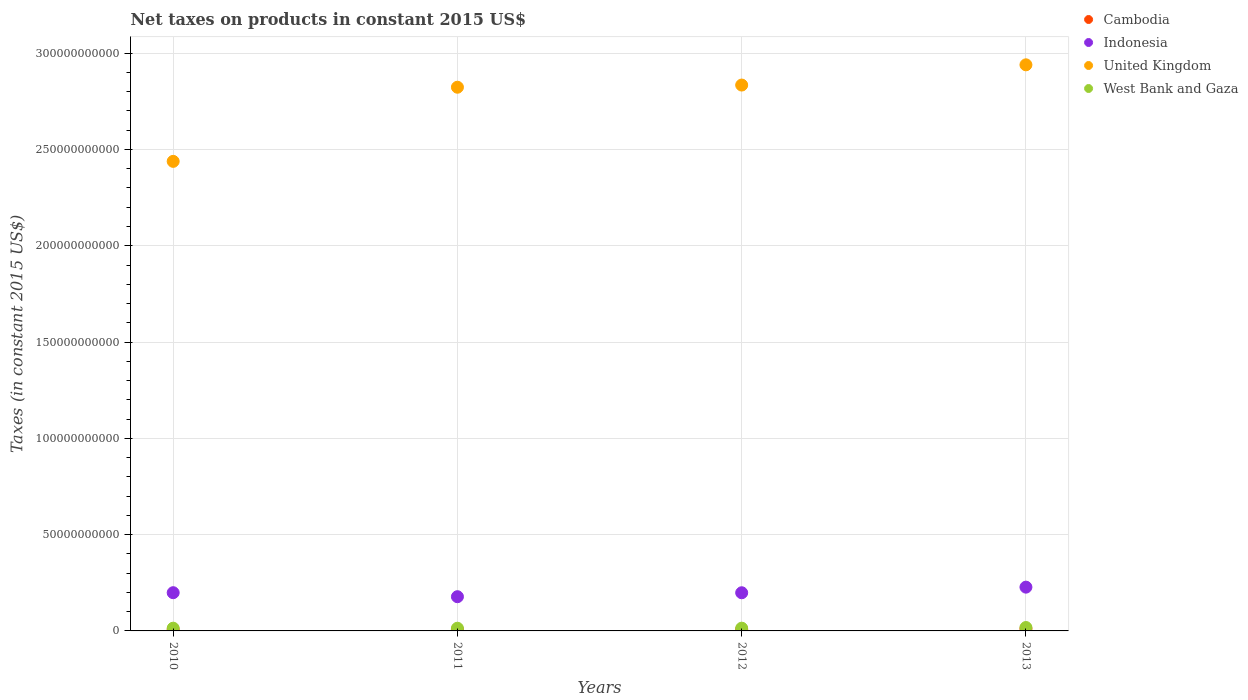Is the number of dotlines equal to the number of legend labels?
Your answer should be very brief. Yes. What is the net taxes on products in United Kingdom in 2010?
Ensure brevity in your answer.  2.44e+11. Across all years, what is the maximum net taxes on products in United Kingdom?
Keep it short and to the point. 2.94e+11. Across all years, what is the minimum net taxes on products in Cambodia?
Your answer should be compact. 6.69e+08. In which year was the net taxes on products in West Bank and Gaza minimum?
Provide a short and direct response. 2011. What is the total net taxes on products in United Kingdom in the graph?
Provide a succinct answer. 1.10e+12. What is the difference between the net taxes on products in West Bank and Gaza in 2011 and that in 2012?
Offer a terse response. -2.49e+07. What is the difference between the net taxes on products in Cambodia in 2011 and the net taxes on products in West Bank and Gaza in 2010?
Keep it short and to the point. -6.77e+08. What is the average net taxes on products in United Kingdom per year?
Provide a short and direct response. 2.76e+11. In the year 2010, what is the difference between the net taxes on products in Cambodia and net taxes on products in West Bank and Gaza?
Offer a terse response. -7.52e+08. In how many years, is the net taxes on products in Cambodia greater than 270000000000 US$?
Give a very brief answer. 0. What is the ratio of the net taxes on products in West Bank and Gaza in 2011 to that in 2013?
Ensure brevity in your answer.  0.79. What is the difference between the highest and the second highest net taxes on products in West Bank and Gaza?
Your answer should be compact. 3.43e+08. What is the difference between the highest and the lowest net taxes on products in United Kingdom?
Your response must be concise. 5.01e+1. Is it the case that in every year, the sum of the net taxes on products in United Kingdom and net taxes on products in Cambodia  is greater than the sum of net taxes on products in West Bank and Gaza and net taxes on products in Indonesia?
Make the answer very short. Yes. Is the net taxes on products in West Bank and Gaza strictly greater than the net taxes on products in United Kingdom over the years?
Offer a very short reply. No. What is the difference between two consecutive major ticks on the Y-axis?
Your answer should be very brief. 5.00e+1. Are the values on the major ticks of Y-axis written in scientific E-notation?
Offer a very short reply. No. Does the graph contain grids?
Your answer should be compact. Yes. Where does the legend appear in the graph?
Offer a terse response. Top right. How many legend labels are there?
Offer a terse response. 4. What is the title of the graph?
Ensure brevity in your answer.  Net taxes on products in constant 2015 US$. What is the label or title of the Y-axis?
Offer a terse response. Taxes (in constant 2015 US$). What is the Taxes (in constant 2015 US$) of Cambodia in 2010?
Provide a succinct answer. 6.69e+08. What is the Taxes (in constant 2015 US$) in Indonesia in 2010?
Your answer should be very brief. 1.99e+1. What is the Taxes (in constant 2015 US$) of United Kingdom in 2010?
Your answer should be very brief. 2.44e+11. What is the Taxes (in constant 2015 US$) of West Bank and Gaza in 2010?
Your answer should be very brief. 1.42e+09. What is the Taxes (in constant 2015 US$) of Cambodia in 2011?
Your answer should be compact. 7.44e+08. What is the Taxes (in constant 2015 US$) in Indonesia in 2011?
Ensure brevity in your answer.  1.78e+1. What is the Taxes (in constant 2015 US$) of United Kingdom in 2011?
Your response must be concise. 2.82e+11. What is the Taxes (in constant 2015 US$) in West Bank and Gaza in 2011?
Provide a short and direct response. 1.40e+09. What is the Taxes (in constant 2015 US$) of Cambodia in 2012?
Keep it short and to the point. 8.06e+08. What is the Taxes (in constant 2015 US$) of Indonesia in 2012?
Offer a very short reply. 1.98e+1. What is the Taxes (in constant 2015 US$) of United Kingdom in 2012?
Your response must be concise. 2.83e+11. What is the Taxes (in constant 2015 US$) in West Bank and Gaza in 2012?
Provide a short and direct response. 1.42e+09. What is the Taxes (in constant 2015 US$) in Cambodia in 2013?
Offer a terse response. 1.09e+09. What is the Taxes (in constant 2015 US$) in Indonesia in 2013?
Your answer should be compact. 2.27e+1. What is the Taxes (in constant 2015 US$) of United Kingdom in 2013?
Offer a terse response. 2.94e+11. What is the Taxes (in constant 2015 US$) of West Bank and Gaza in 2013?
Give a very brief answer. 1.77e+09. Across all years, what is the maximum Taxes (in constant 2015 US$) in Cambodia?
Offer a terse response. 1.09e+09. Across all years, what is the maximum Taxes (in constant 2015 US$) of Indonesia?
Offer a very short reply. 2.27e+1. Across all years, what is the maximum Taxes (in constant 2015 US$) of United Kingdom?
Provide a short and direct response. 2.94e+11. Across all years, what is the maximum Taxes (in constant 2015 US$) of West Bank and Gaza?
Your answer should be very brief. 1.77e+09. Across all years, what is the minimum Taxes (in constant 2015 US$) of Cambodia?
Provide a short and direct response. 6.69e+08. Across all years, what is the minimum Taxes (in constant 2015 US$) of Indonesia?
Make the answer very short. 1.78e+1. Across all years, what is the minimum Taxes (in constant 2015 US$) of United Kingdom?
Ensure brevity in your answer.  2.44e+11. Across all years, what is the minimum Taxes (in constant 2015 US$) in West Bank and Gaza?
Give a very brief answer. 1.40e+09. What is the total Taxes (in constant 2015 US$) in Cambodia in the graph?
Offer a very short reply. 3.31e+09. What is the total Taxes (in constant 2015 US$) of Indonesia in the graph?
Ensure brevity in your answer.  8.02e+1. What is the total Taxes (in constant 2015 US$) of United Kingdom in the graph?
Your answer should be compact. 1.10e+12. What is the total Taxes (in constant 2015 US$) of West Bank and Gaza in the graph?
Offer a very short reply. 6.01e+09. What is the difference between the Taxes (in constant 2015 US$) in Cambodia in 2010 and that in 2011?
Provide a succinct answer. -7.49e+07. What is the difference between the Taxes (in constant 2015 US$) in Indonesia in 2010 and that in 2011?
Your answer should be very brief. 2.08e+09. What is the difference between the Taxes (in constant 2015 US$) in United Kingdom in 2010 and that in 2011?
Ensure brevity in your answer.  -3.85e+1. What is the difference between the Taxes (in constant 2015 US$) in West Bank and Gaza in 2010 and that in 2011?
Your answer should be compact. 2.16e+07. What is the difference between the Taxes (in constant 2015 US$) of Cambodia in 2010 and that in 2012?
Provide a short and direct response. -1.37e+08. What is the difference between the Taxes (in constant 2015 US$) in Indonesia in 2010 and that in 2012?
Your response must be concise. 3.49e+07. What is the difference between the Taxes (in constant 2015 US$) in United Kingdom in 2010 and that in 2012?
Provide a succinct answer. -3.96e+1. What is the difference between the Taxes (in constant 2015 US$) of West Bank and Gaza in 2010 and that in 2012?
Keep it short and to the point. -3.32e+06. What is the difference between the Taxes (in constant 2015 US$) of Cambodia in 2010 and that in 2013?
Your answer should be compact. -4.25e+08. What is the difference between the Taxes (in constant 2015 US$) in Indonesia in 2010 and that in 2013?
Your answer should be compact. -2.88e+09. What is the difference between the Taxes (in constant 2015 US$) in United Kingdom in 2010 and that in 2013?
Ensure brevity in your answer.  -5.01e+1. What is the difference between the Taxes (in constant 2015 US$) in West Bank and Gaza in 2010 and that in 2013?
Your response must be concise. -3.46e+08. What is the difference between the Taxes (in constant 2015 US$) in Cambodia in 2011 and that in 2012?
Provide a succinct answer. -6.22e+07. What is the difference between the Taxes (in constant 2015 US$) of Indonesia in 2011 and that in 2012?
Your answer should be very brief. -2.05e+09. What is the difference between the Taxes (in constant 2015 US$) of United Kingdom in 2011 and that in 2012?
Give a very brief answer. -1.12e+09. What is the difference between the Taxes (in constant 2015 US$) of West Bank and Gaza in 2011 and that in 2012?
Keep it short and to the point. -2.49e+07. What is the difference between the Taxes (in constant 2015 US$) of Cambodia in 2011 and that in 2013?
Offer a terse response. -3.50e+08. What is the difference between the Taxes (in constant 2015 US$) in Indonesia in 2011 and that in 2013?
Keep it short and to the point. -4.96e+09. What is the difference between the Taxes (in constant 2015 US$) in United Kingdom in 2011 and that in 2013?
Offer a terse response. -1.16e+1. What is the difference between the Taxes (in constant 2015 US$) in West Bank and Gaza in 2011 and that in 2013?
Offer a very short reply. -3.68e+08. What is the difference between the Taxes (in constant 2015 US$) of Cambodia in 2012 and that in 2013?
Provide a succinct answer. -2.88e+08. What is the difference between the Taxes (in constant 2015 US$) of Indonesia in 2012 and that in 2013?
Provide a short and direct response. -2.92e+09. What is the difference between the Taxes (in constant 2015 US$) in United Kingdom in 2012 and that in 2013?
Offer a very short reply. -1.05e+1. What is the difference between the Taxes (in constant 2015 US$) of West Bank and Gaza in 2012 and that in 2013?
Make the answer very short. -3.43e+08. What is the difference between the Taxes (in constant 2015 US$) of Cambodia in 2010 and the Taxes (in constant 2015 US$) of Indonesia in 2011?
Offer a terse response. -1.71e+1. What is the difference between the Taxes (in constant 2015 US$) of Cambodia in 2010 and the Taxes (in constant 2015 US$) of United Kingdom in 2011?
Provide a succinct answer. -2.82e+11. What is the difference between the Taxes (in constant 2015 US$) of Cambodia in 2010 and the Taxes (in constant 2015 US$) of West Bank and Gaza in 2011?
Your answer should be compact. -7.30e+08. What is the difference between the Taxes (in constant 2015 US$) in Indonesia in 2010 and the Taxes (in constant 2015 US$) in United Kingdom in 2011?
Provide a short and direct response. -2.62e+11. What is the difference between the Taxes (in constant 2015 US$) of Indonesia in 2010 and the Taxes (in constant 2015 US$) of West Bank and Gaza in 2011?
Ensure brevity in your answer.  1.85e+1. What is the difference between the Taxes (in constant 2015 US$) of United Kingdom in 2010 and the Taxes (in constant 2015 US$) of West Bank and Gaza in 2011?
Ensure brevity in your answer.  2.42e+11. What is the difference between the Taxes (in constant 2015 US$) in Cambodia in 2010 and the Taxes (in constant 2015 US$) in Indonesia in 2012?
Offer a terse response. -1.91e+1. What is the difference between the Taxes (in constant 2015 US$) of Cambodia in 2010 and the Taxes (in constant 2015 US$) of United Kingdom in 2012?
Provide a short and direct response. -2.83e+11. What is the difference between the Taxes (in constant 2015 US$) in Cambodia in 2010 and the Taxes (in constant 2015 US$) in West Bank and Gaza in 2012?
Offer a terse response. -7.55e+08. What is the difference between the Taxes (in constant 2015 US$) in Indonesia in 2010 and the Taxes (in constant 2015 US$) in United Kingdom in 2012?
Provide a succinct answer. -2.64e+11. What is the difference between the Taxes (in constant 2015 US$) of Indonesia in 2010 and the Taxes (in constant 2015 US$) of West Bank and Gaza in 2012?
Keep it short and to the point. 1.84e+1. What is the difference between the Taxes (in constant 2015 US$) in United Kingdom in 2010 and the Taxes (in constant 2015 US$) in West Bank and Gaza in 2012?
Give a very brief answer. 2.42e+11. What is the difference between the Taxes (in constant 2015 US$) in Cambodia in 2010 and the Taxes (in constant 2015 US$) in Indonesia in 2013?
Your answer should be compact. -2.21e+1. What is the difference between the Taxes (in constant 2015 US$) in Cambodia in 2010 and the Taxes (in constant 2015 US$) in United Kingdom in 2013?
Provide a short and direct response. -2.93e+11. What is the difference between the Taxes (in constant 2015 US$) of Cambodia in 2010 and the Taxes (in constant 2015 US$) of West Bank and Gaza in 2013?
Offer a terse response. -1.10e+09. What is the difference between the Taxes (in constant 2015 US$) in Indonesia in 2010 and the Taxes (in constant 2015 US$) in United Kingdom in 2013?
Your response must be concise. -2.74e+11. What is the difference between the Taxes (in constant 2015 US$) in Indonesia in 2010 and the Taxes (in constant 2015 US$) in West Bank and Gaza in 2013?
Provide a succinct answer. 1.81e+1. What is the difference between the Taxes (in constant 2015 US$) in United Kingdom in 2010 and the Taxes (in constant 2015 US$) in West Bank and Gaza in 2013?
Ensure brevity in your answer.  2.42e+11. What is the difference between the Taxes (in constant 2015 US$) in Cambodia in 2011 and the Taxes (in constant 2015 US$) in Indonesia in 2012?
Provide a short and direct response. -1.91e+1. What is the difference between the Taxes (in constant 2015 US$) of Cambodia in 2011 and the Taxes (in constant 2015 US$) of United Kingdom in 2012?
Your answer should be compact. -2.83e+11. What is the difference between the Taxes (in constant 2015 US$) of Cambodia in 2011 and the Taxes (in constant 2015 US$) of West Bank and Gaza in 2012?
Provide a succinct answer. -6.80e+08. What is the difference between the Taxes (in constant 2015 US$) in Indonesia in 2011 and the Taxes (in constant 2015 US$) in United Kingdom in 2012?
Keep it short and to the point. -2.66e+11. What is the difference between the Taxes (in constant 2015 US$) in Indonesia in 2011 and the Taxes (in constant 2015 US$) in West Bank and Gaza in 2012?
Provide a short and direct response. 1.63e+1. What is the difference between the Taxes (in constant 2015 US$) of United Kingdom in 2011 and the Taxes (in constant 2015 US$) of West Bank and Gaza in 2012?
Keep it short and to the point. 2.81e+11. What is the difference between the Taxes (in constant 2015 US$) of Cambodia in 2011 and the Taxes (in constant 2015 US$) of Indonesia in 2013?
Your answer should be compact. -2.20e+1. What is the difference between the Taxes (in constant 2015 US$) in Cambodia in 2011 and the Taxes (in constant 2015 US$) in United Kingdom in 2013?
Keep it short and to the point. -2.93e+11. What is the difference between the Taxes (in constant 2015 US$) in Cambodia in 2011 and the Taxes (in constant 2015 US$) in West Bank and Gaza in 2013?
Give a very brief answer. -1.02e+09. What is the difference between the Taxes (in constant 2015 US$) in Indonesia in 2011 and the Taxes (in constant 2015 US$) in United Kingdom in 2013?
Make the answer very short. -2.76e+11. What is the difference between the Taxes (in constant 2015 US$) in Indonesia in 2011 and the Taxes (in constant 2015 US$) in West Bank and Gaza in 2013?
Your answer should be compact. 1.60e+1. What is the difference between the Taxes (in constant 2015 US$) of United Kingdom in 2011 and the Taxes (in constant 2015 US$) of West Bank and Gaza in 2013?
Make the answer very short. 2.81e+11. What is the difference between the Taxes (in constant 2015 US$) of Cambodia in 2012 and the Taxes (in constant 2015 US$) of Indonesia in 2013?
Your response must be concise. -2.19e+1. What is the difference between the Taxes (in constant 2015 US$) in Cambodia in 2012 and the Taxes (in constant 2015 US$) in United Kingdom in 2013?
Give a very brief answer. -2.93e+11. What is the difference between the Taxes (in constant 2015 US$) in Cambodia in 2012 and the Taxes (in constant 2015 US$) in West Bank and Gaza in 2013?
Ensure brevity in your answer.  -9.61e+08. What is the difference between the Taxes (in constant 2015 US$) of Indonesia in 2012 and the Taxes (in constant 2015 US$) of United Kingdom in 2013?
Offer a terse response. -2.74e+11. What is the difference between the Taxes (in constant 2015 US$) of Indonesia in 2012 and the Taxes (in constant 2015 US$) of West Bank and Gaza in 2013?
Provide a short and direct response. 1.80e+1. What is the difference between the Taxes (in constant 2015 US$) in United Kingdom in 2012 and the Taxes (in constant 2015 US$) in West Bank and Gaza in 2013?
Keep it short and to the point. 2.82e+11. What is the average Taxes (in constant 2015 US$) in Cambodia per year?
Ensure brevity in your answer.  8.28e+08. What is the average Taxes (in constant 2015 US$) in Indonesia per year?
Give a very brief answer. 2.00e+1. What is the average Taxes (in constant 2015 US$) in United Kingdom per year?
Offer a very short reply. 2.76e+11. What is the average Taxes (in constant 2015 US$) in West Bank and Gaza per year?
Provide a succinct answer. 1.50e+09. In the year 2010, what is the difference between the Taxes (in constant 2015 US$) of Cambodia and Taxes (in constant 2015 US$) of Indonesia?
Ensure brevity in your answer.  -1.92e+1. In the year 2010, what is the difference between the Taxes (in constant 2015 US$) of Cambodia and Taxes (in constant 2015 US$) of United Kingdom?
Provide a short and direct response. -2.43e+11. In the year 2010, what is the difference between the Taxes (in constant 2015 US$) in Cambodia and Taxes (in constant 2015 US$) in West Bank and Gaza?
Give a very brief answer. -7.52e+08. In the year 2010, what is the difference between the Taxes (in constant 2015 US$) in Indonesia and Taxes (in constant 2015 US$) in United Kingdom?
Offer a very short reply. -2.24e+11. In the year 2010, what is the difference between the Taxes (in constant 2015 US$) of Indonesia and Taxes (in constant 2015 US$) of West Bank and Gaza?
Your answer should be compact. 1.84e+1. In the year 2010, what is the difference between the Taxes (in constant 2015 US$) of United Kingdom and Taxes (in constant 2015 US$) of West Bank and Gaza?
Ensure brevity in your answer.  2.42e+11. In the year 2011, what is the difference between the Taxes (in constant 2015 US$) of Cambodia and Taxes (in constant 2015 US$) of Indonesia?
Keep it short and to the point. -1.70e+1. In the year 2011, what is the difference between the Taxes (in constant 2015 US$) of Cambodia and Taxes (in constant 2015 US$) of United Kingdom?
Ensure brevity in your answer.  -2.82e+11. In the year 2011, what is the difference between the Taxes (in constant 2015 US$) of Cambodia and Taxes (in constant 2015 US$) of West Bank and Gaza?
Your answer should be compact. -6.55e+08. In the year 2011, what is the difference between the Taxes (in constant 2015 US$) in Indonesia and Taxes (in constant 2015 US$) in United Kingdom?
Offer a terse response. -2.65e+11. In the year 2011, what is the difference between the Taxes (in constant 2015 US$) in Indonesia and Taxes (in constant 2015 US$) in West Bank and Gaza?
Offer a terse response. 1.64e+1. In the year 2011, what is the difference between the Taxes (in constant 2015 US$) of United Kingdom and Taxes (in constant 2015 US$) of West Bank and Gaza?
Make the answer very short. 2.81e+11. In the year 2012, what is the difference between the Taxes (in constant 2015 US$) of Cambodia and Taxes (in constant 2015 US$) of Indonesia?
Keep it short and to the point. -1.90e+1. In the year 2012, what is the difference between the Taxes (in constant 2015 US$) of Cambodia and Taxes (in constant 2015 US$) of United Kingdom?
Make the answer very short. -2.83e+11. In the year 2012, what is the difference between the Taxes (in constant 2015 US$) of Cambodia and Taxes (in constant 2015 US$) of West Bank and Gaza?
Offer a very short reply. -6.18e+08. In the year 2012, what is the difference between the Taxes (in constant 2015 US$) in Indonesia and Taxes (in constant 2015 US$) in United Kingdom?
Ensure brevity in your answer.  -2.64e+11. In the year 2012, what is the difference between the Taxes (in constant 2015 US$) in Indonesia and Taxes (in constant 2015 US$) in West Bank and Gaza?
Your answer should be compact. 1.84e+1. In the year 2012, what is the difference between the Taxes (in constant 2015 US$) of United Kingdom and Taxes (in constant 2015 US$) of West Bank and Gaza?
Keep it short and to the point. 2.82e+11. In the year 2013, what is the difference between the Taxes (in constant 2015 US$) of Cambodia and Taxes (in constant 2015 US$) of Indonesia?
Give a very brief answer. -2.16e+1. In the year 2013, what is the difference between the Taxes (in constant 2015 US$) of Cambodia and Taxes (in constant 2015 US$) of United Kingdom?
Your response must be concise. -2.93e+11. In the year 2013, what is the difference between the Taxes (in constant 2015 US$) of Cambodia and Taxes (in constant 2015 US$) of West Bank and Gaza?
Your answer should be very brief. -6.73e+08. In the year 2013, what is the difference between the Taxes (in constant 2015 US$) in Indonesia and Taxes (in constant 2015 US$) in United Kingdom?
Keep it short and to the point. -2.71e+11. In the year 2013, what is the difference between the Taxes (in constant 2015 US$) in Indonesia and Taxes (in constant 2015 US$) in West Bank and Gaza?
Provide a short and direct response. 2.10e+1. In the year 2013, what is the difference between the Taxes (in constant 2015 US$) in United Kingdom and Taxes (in constant 2015 US$) in West Bank and Gaza?
Offer a very short reply. 2.92e+11. What is the ratio of the Taxes (in constant 2015 US$) in Cambodia in 2010 to that in 2011?
Your answer should be compact. 0.9. What is the ratio of the Taxes (in constant 2015 US$) of Indonesia in 2010 to that in 2011?
Give a very brief answer. 1.12. What is the ratio of the Taxes (in constant 2015 US$) in United Kingdom in 2010 to that in 2011?
Ensure brevity in your answer.  0.86. What is the ratio of the Taxes (in constant 2015 US$) in West Bank and Gaza in 2010 to that in 2011?
Offer a very short reply. 1.02. What is the ratio of the Taxes (in constant 2015 US$) in Cambodia in 2010 to that in 2012?
Your answer should be compact. 0.83. What is the ratio of the Taxes (in constant 2015 US$) of United Kingdom in 2010 to that in 2012?
Offer a very short reply. 0.86. What is the ratio of the Taxes (in constant 2015 US$) of West Bank and Gaza in 2010 to that in 2012?
Offer a very short reply. 1. What is the ratio of the Taxes (in constant 2015 US$) in Cambodia in 2010 to that in 2013?
Your answer should be very brief. 0.61. What is the ratio of the Taxes (in constant 2015 US$) in Indonesia in 2010 to that in 2013?
Offer a terse response. 0.87. What is the ratio of the Taxes (in constant 2015 US$) of United Kingdom in 2010 to that in 2013?
Offer a terse response. 0.83. What is the ratio of the Taxes (in constant 2015 US$) of West Bank and Gaza in 2010 to that in 2013?
Provide a short and direct response. 0.8. What is the ratio of the Taxes (in constant 2015 US$) of Cambodia in 2011 to that in 2012?
Provide a short and direct response. 0.92. What is the ratio of the Taxes (in constant 2015 US$) of Indonesia in 2011 to that in 2012?
Offer a very short reply. 0.9. What is the ratio of the Taxes (in constant 2015 US$) in United Kingdom in 2011 to that in 2012?
Make the answer very short. 1. What is the ratio of the Taxes (in constant 2015 US$) of West Bank and Gaza in 2011 to that in 2012?
Ensure brevity in your answer.  0.98. What is the ratio of the Taxes (in constant 2015 US$) of Cambodia in 2011 to that in 2013?
Make the answer very short. 0.68. What is the ratio of the Taxes (in constant 2015 US$) of Indonesia in 2011 to that in 2013?
Your answer should be compact. 0.78. What is the ratio of the Taxes (in constant 2015 US$) in United Kingdom in 2011 to that in 2013?
Provide a succinct answer. 0.96. What is the ratio of the Taxes (in constant 2015 US$) in West Bank and Gaza in 2011 to that in 2013?
Your response must be concise. 0.79. What is the ratio of the Taxes (in constant 2015 US$) of Cambodia in 2012 to that in 2013?
Your response must be concise. 0.74. What is the ratio of the Taxes (in constant 2015 US$) in Indonesia in 2012 to that in 2013?
Your response must be concise. 0.87. What is the ratio of the Taxes (in constant 2015 US$) in United Kingdom in 2012 to that in 2013?
Provide a succinct answer. 0.96. What is the ratio of the Taxes (in constant 2015 US$) in West Bank and Gaza in 2012 to that in 2013?
Offer a very short reply. 0.81. What is the difference between the highest and the second highest Taxes (in constant 2015 US$) of Cambodia?
Offer a very short reply. 2.88e+08. What is the difference between the highest and the second highest Taxes (in constant 2015 US$) in Indonesia?
Ensure brevity in your answer.  2.88e+09. What is the difference between the highest and the second highest Taxes (in constant 2015 US$) in United Kingdom?
Make the answer very short. 1.05e+1. What is the difference between the highest and the second highest Taxes (in constant 2015 US$) of West Bank and Gaza?
Keep it short and to the point. 3.43e+08. What is the difference between the highest and the lowest Taxes (in constant 2015 US$) of Cambodia?
Give a very brief answer. 4.25e+08. What is the difference between the highest and the lowest Taxes (in constant 2015 US$) of Indonesia?
Offer a very short reply. 4.96e+09. What is the difference between the highest and the lowest Taxes (in constant 2015 US$) of United Kingdom?
Offer a very short reply. 5.01e+1. What is the difference between the highest and the lowest Taxes (in constant 2015 US$) in West Bank and Gaza?
Keep it short and to the point. 3.68e+08. 